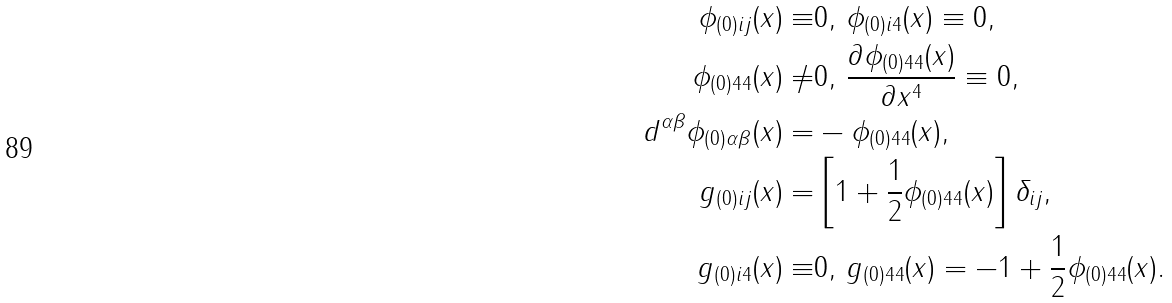Convert formula to latex. <formula><loc_0><loc_0><loc_500><loc_500>\phi _ { ( 0 ) i j } ( x ) \equiv & 0 , \, \phi _ { ( 0 ) i 4 } ( x ) \equiv 0 , \\ \phi _ { ( 0 ) 4 4 } ( x ) \neq & 0 , \, \frac { \partial \phi _ { ( 0 ) 4 4 } ( x ) } { \partial x ^ { 4 } } \equiv 0 , \\ d ^ { \alpha \beta } \phi _ { ( 0 ) \alpha \beta } ( x ) = & - \phi _ { ( 0 ) 4 4 } ( x ) , \\ g _ { ( 0 ) i j } ( x ) = & \left [ 1 + \frac { 1 } { 2 } \phi _ { ( 0 ) 4 4 } ( x ) \right ] \delta _ { i j } , \\ g _ { ( 0 ) i 4 } ( x ) \equiv & 0 , \, g _ { ( 0 ) 4 4 } ( x ) = - 1 + \frac { 1 } { 2 } \phi _ { ( 0 ) 4 4 } ( x ) .</formula> 